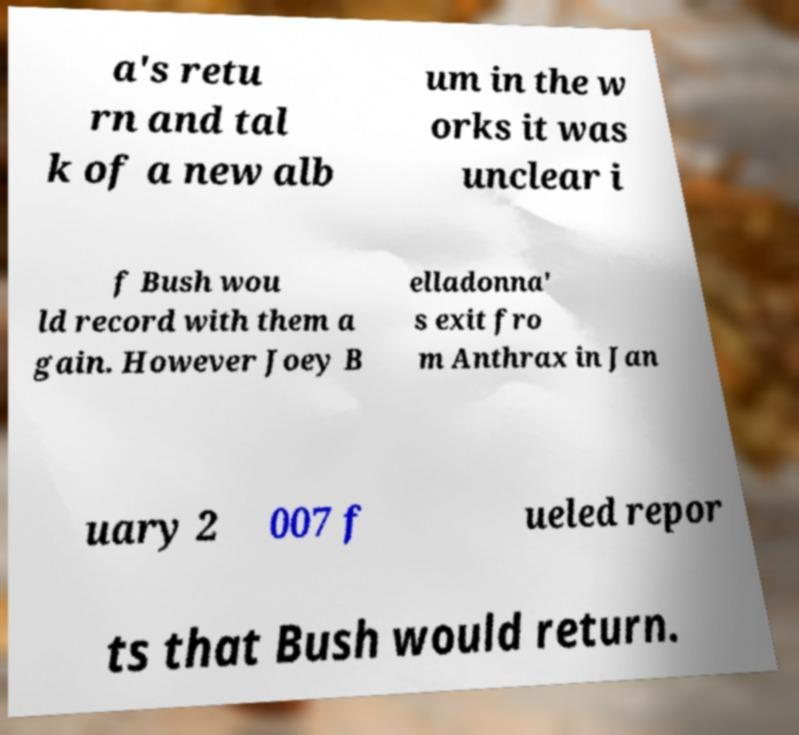Could you extract and type out the text from this image? a's retu rn and tal k of a new alb um in the w orks it was unclear i f Bush wou ld record with them a gain. However Joey B elladonna' s exit fro m Anthrax in Jan uary 2 007 f ueled repor ts that Bush would return. 